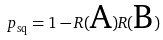Convert formula to latex. <formula><loc_0><loc_0><loc_500><loc_500>p _ { \text {sq} } = 1 - R ( \text {A} ) R ( \text {B} )</formula> 